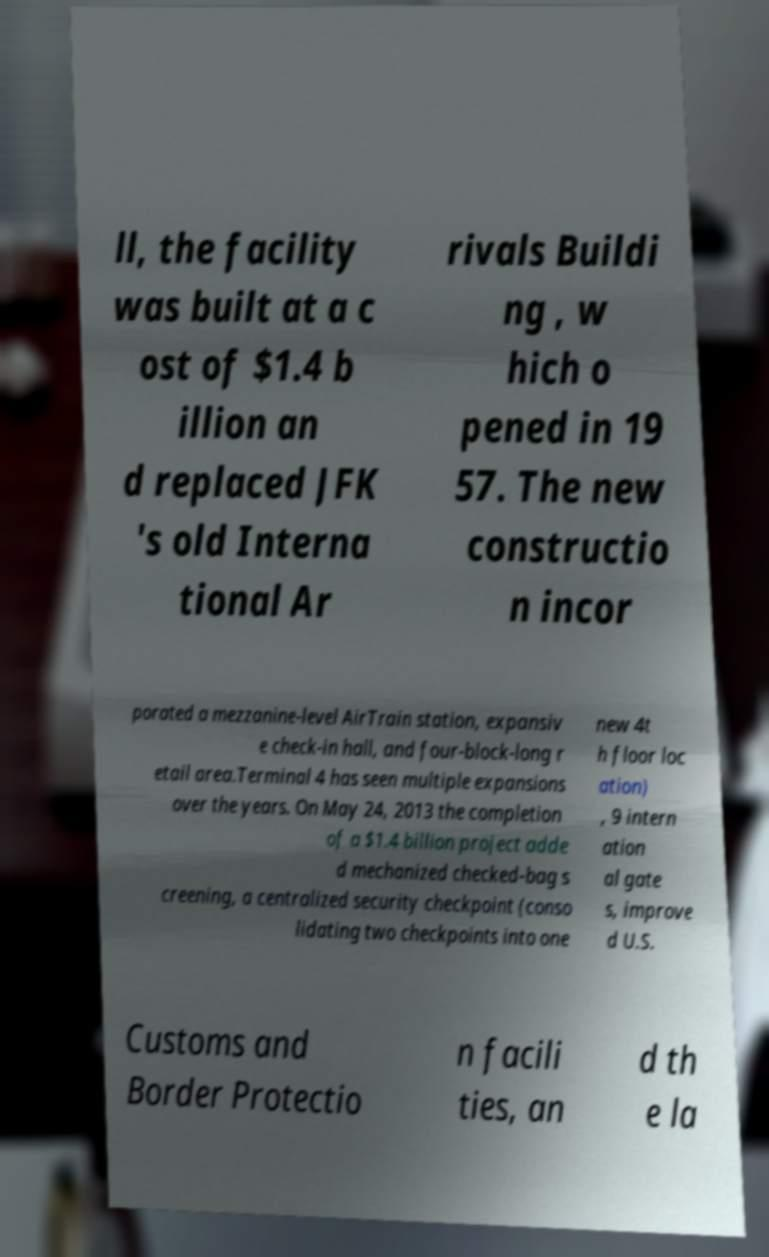I need the written content from this picture converted into text. Can you do that? ll, the facility was built at a c ost of $1.4 b illion an d replaced JFK 's old Interna tional Ar rivals Buildi ng , w hich o pened in 19 57. The new constructio n incor porated a mezzanine-level AirTrain station, expansiv e check-in hall, and four-block-long r etail area.Terminal 4 has seen multiple expansions over the years. On May 24, 2013 the completion of a $1.4 billion project adde d mechanized checked-bag s creening, a centralized security checkpoint (conso lidating two checkpoints into one new 4t h floor loc ation) , 9 intern ation al gate s, improve d U.S. Customs and Border Protectio n facili ties, an d th e la 